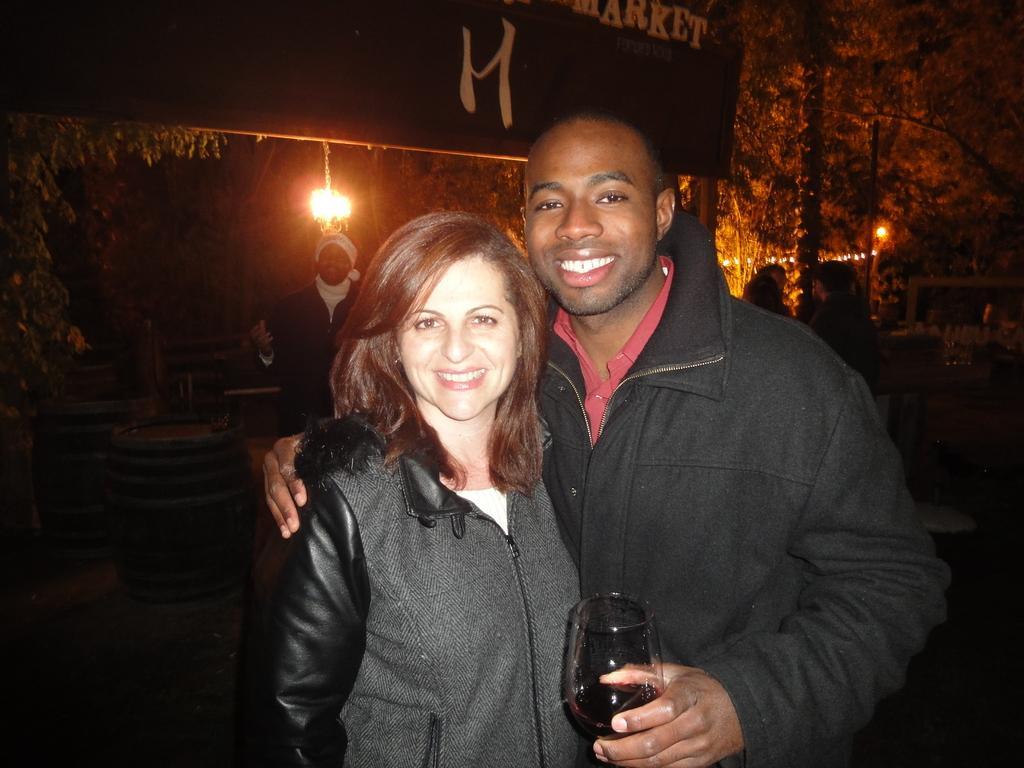Can you describe this image briefly? In the picture we can see a man and a woman standing together they are wearing a jacket and a man is holding a wine glass and they are smiling and behind them, we can see a shop with a person standing and to the shop we can see a light and besides we can see trees and light 